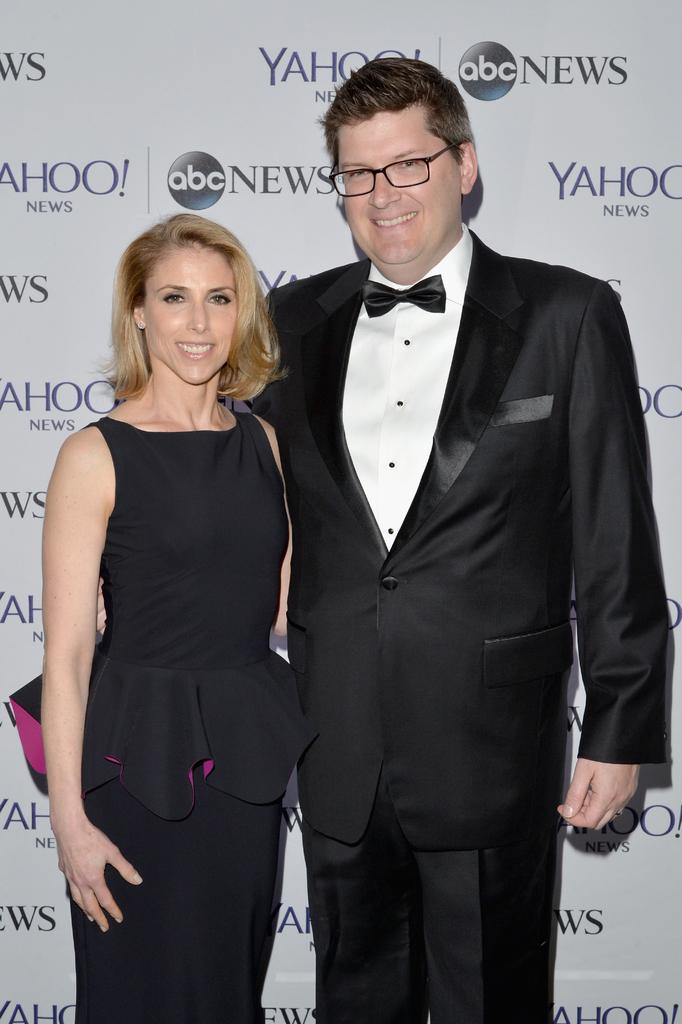What companies sponsored this event?
Give a very brief answer. Yahoo. 